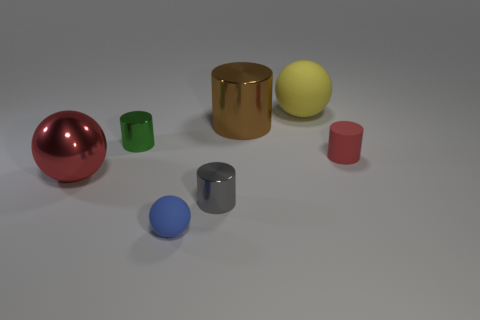Is the color of the large metallic ball the same as the tiny matte cylinder?
Provide a succinct answer. Yes. Does the small cylinder in front of the red metallic object have the same material as the red thing right of the green metal object?
Give a very brief answer. No. Are the ball on the right side of the large brown metallic cylinder and the blue ball made of the same material?
Ensure brevity in your answer.  Yes. The other large matte object that is the same shape as the blue rubber thing is what color?
Offer a very short reply. Yellow. There is a object to the left of the tiny green cylinder; is its color the same as the small matte cylinder?
Provide a short and direct response. Yes. Are there any large metal spheres in front of the tiny rubber cylinder?
Make the answer very short. Yes. What is the color of the sphere that is both behind the blue ball and to the right of the green thing?
Keep it short and to the point. Yellow. The big thing that is the same color as the small rubber cylinder is what shape?
Ensure brevity in your answer.  Sphere. There is a rubber ball that is behind the large object in front of the small rubber cylinder; how big is it?
Your response must be concise. Large. What number of blocks are either big red metallic things or red rubber things?
Your answer should be very brief. 0. 